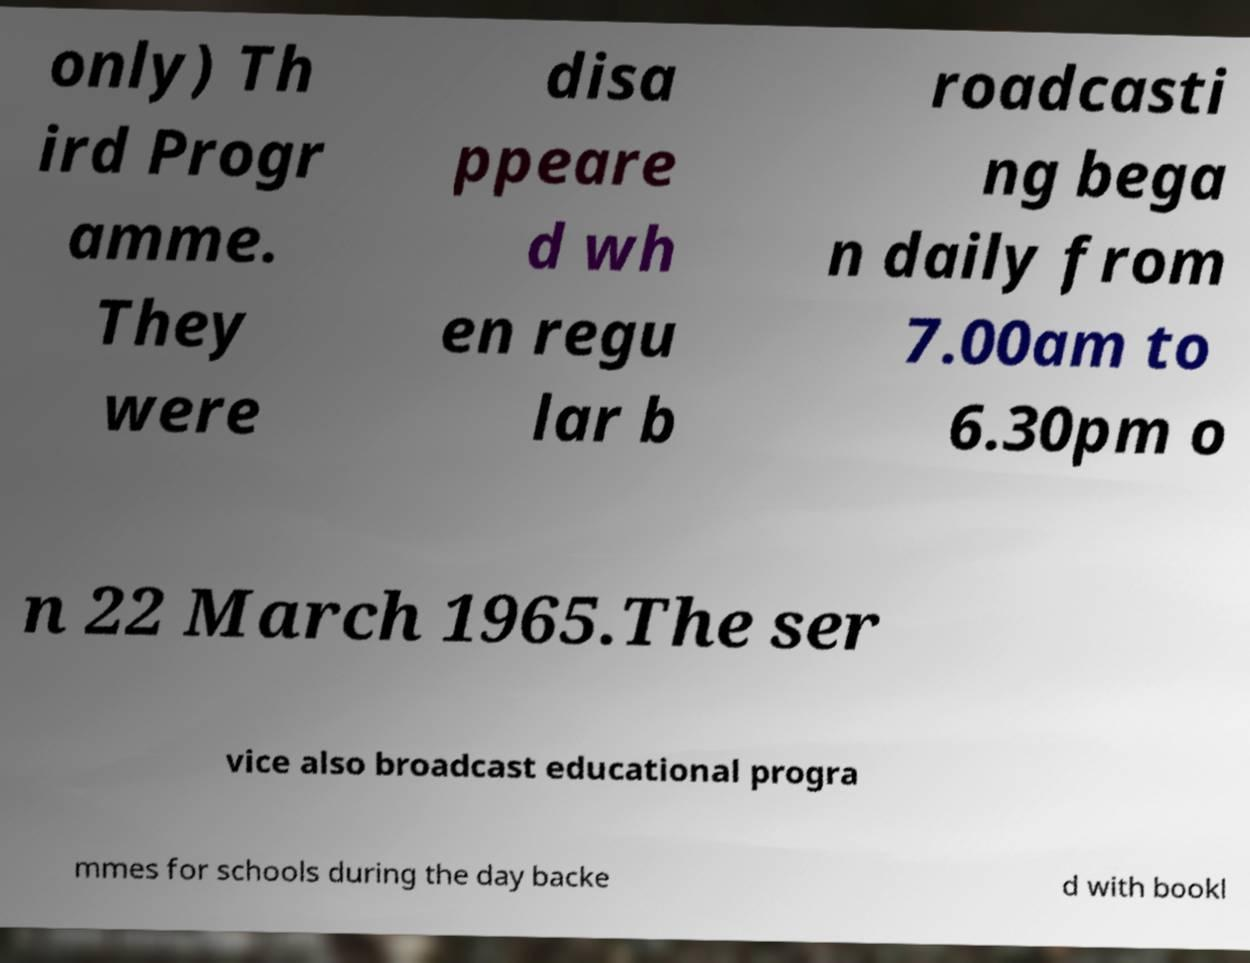Please identify and transcribe the text found in this image. only) Th ird Progr amme. They were disa ppeare d wh en regu lar b roadcasti ng bega n daily from 7.00am to 6.30pm o n 22 March 1965.The ser vice also broadcast educational progra mmes for schools during the day backe d with bookl 